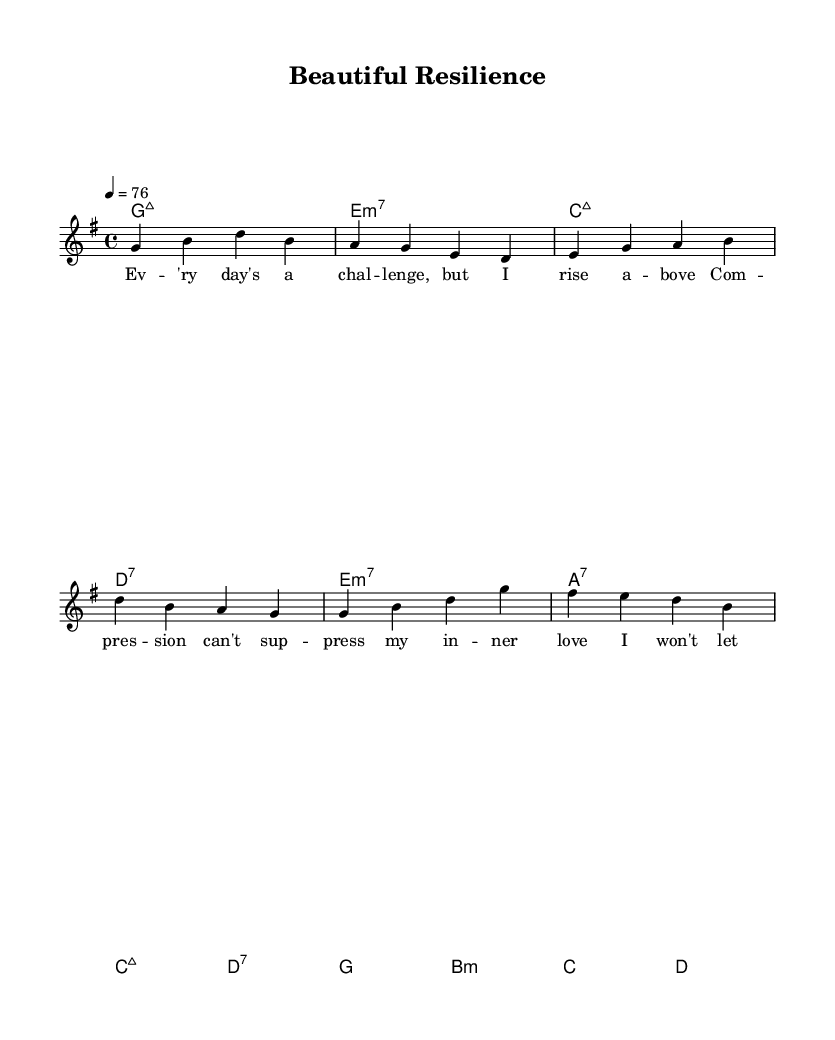What is the key signature of this music? The key signature is G major, indicated by one sharp (F#) in the key signature of the score.
Answer: G major What is the time signature of this music? The time signature is 4/4, which means there are four beats per measure and the quarter note receives one beat.
Answer: 4/4 What is the tempo marking of the music? The tempo marking indicates a speed of 76 beats per minute, which is given at the beginning of the score.
Answer: 76 How many measures are in the verse section? The verse section consists of 4 measures, as indicated by the grouping of notes written under the melody line.
Answer: 4 What is the last line of the chorus lyrics? The last line of the chorus lyrics is "I'm beautiful, I'm resilient," which can be observed from the lyric section of the score.
Answer: I'm beautiful, I'm resilient Which chord accompanies the pre-chorus? The pre-chorus is accompanied by an E minor seventh chord, which is written above the melody in the harmonies section.
Answer: E minor seventh What musical genre does this piece belong to? This piece belongs to the genre of Rhythm and Blues, specifically Contemporary R&B, as indicated by the title and lyrical themes in the sheet music.
Answer: Rhythm and Blues 